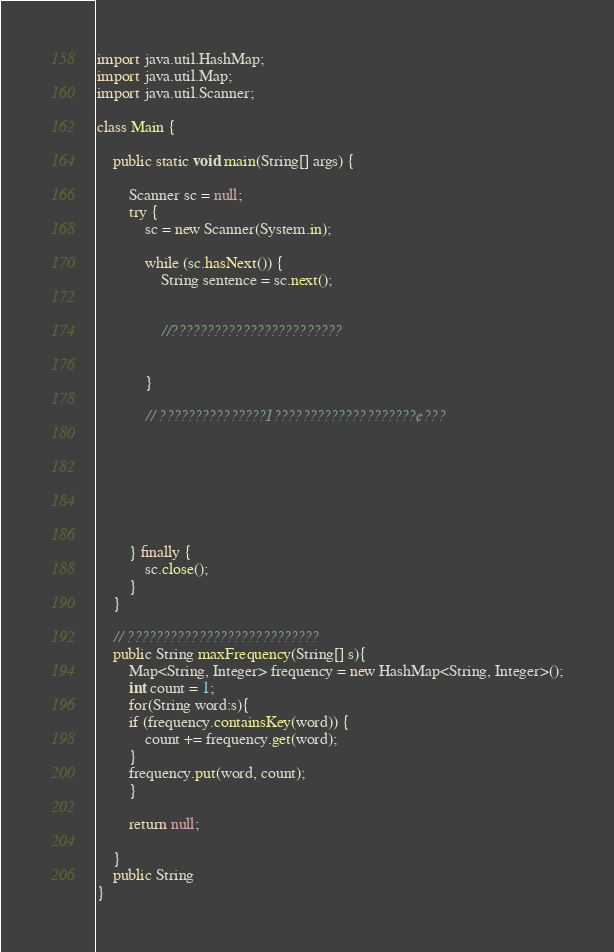<code> <loc_0><loc_0><loc_500><loc_500><_Java_>import java.util.HashMap;
import java.util.Map;
import java.util.Scanner;

class Main {

	public static void main(String[] args) {

		Scanner sc = null;
		try {
			sc = new Scanner(System.in);
			
			while (sc.hasNext()) {
				String sentence = sc.next();
				
				
				//????????????????????????
				
				
			}

			// ???????????????1????????????????????¢???
			
			
			
			
			
			

		} finally {
			sc.close();
		}
	}
	
	// ???????????????????????????
	public String maxFrequency(String[] s){
		Map<String, Integer> frequency = new HashMap<String, Integer>();
		int count = 1;
		for(String word:s){
		if (frequency.containsKey(word)) {
			count += frequency.get(word);
		}
		frequency.put(word, count);
		}
		
		return null;
		
	}
	public String 
}</code> 